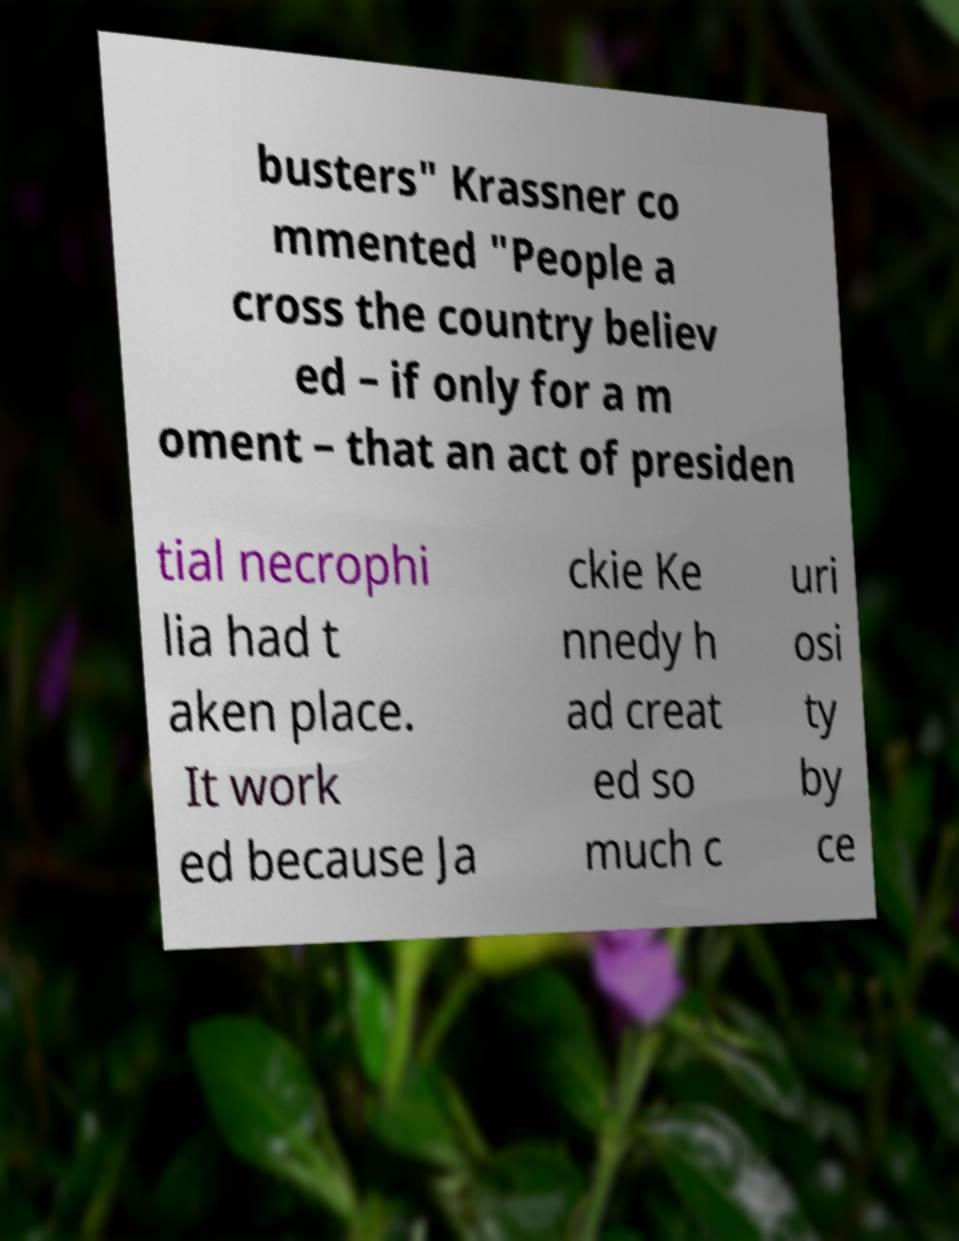Please identify and transcribe the text found in this image. busters" Krassner co mmented "People a cross the country believ ed – if only for a m oment – that an act of presiden tial necrophi lia had t aken place. It work ed because Ja ckie Ke nnedy h ad creat ed so much c uri osi ty by ce 